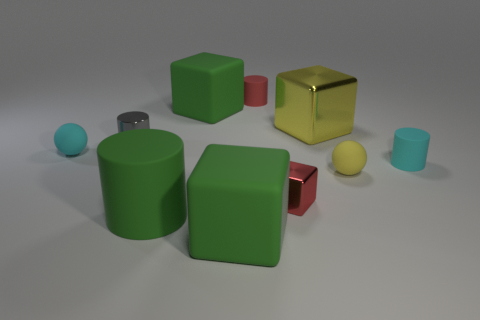There is a tiny gray metal cylinder that is to the left of the tiny red rubber object; how many balls are left of it?
Your answer should be very brief. 1. How many yellow things have the same material as the big yellow cube?
Offer a very short reply. 0. How many big objects are red matte spheres or shiny things?
Keep it short and to the point. 1. There is a rubber object that is both behind the green matte cylinder and in front of the small cyan rubber cylinder; what shape is it?
Offer a very short reply. Sphere. Is the red block made of the same material as the yellow ball?
Give a very brief answer. No. What color is the other rubber cylinder that is the same size as the cyan cylinder?
Offer a very short reply. Red. The large object that is both behind the small yellow ball and left of the tiny metal cube is what color?
Give a very brief answer. Green. What size is the rubber object that is the same color as the big shiny block?
Make the answer very short. Small. The object that is the same color as the tiny metal cube is what shape?
Give a very brief answer. Cylinder. There is a cube that is left of the big rubber block to the right of the large green cube that is behind the cyan cylinder; how big is it?
Offer a very short reply. Large. 